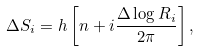<formula> <loc_0><loc_0><loc_500><loc_500>\Delta S _ { i } = h \left [ n + i \frac { \Delta \log R _ { i } } { 2 \pi } \right ] ,</formula> 